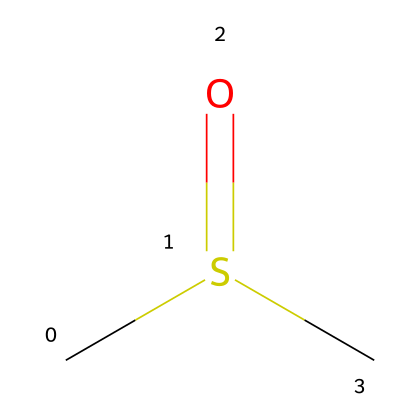What is the molecular formula of DMSO? The SMILES notation reveals the types and number of atoms present. By analyzing CS(=O)C, we deduce that there are two carbon atoms (C), one sulfur atom (S), and one oxygen atom (O) in the structure. Thus, the molecular formula combines these into C2H6OS.
Answer: C2H6OS How many carbon atoms are present in DMSO? By examining the SMILES representation, CS(=O)C, we identify that there are two "C" symbols indicating the presence of two carbon atoms in the structure.
Answer: 2 What is the hybridization of the sulfur atom in DMSO? The structure includes sulfur bonded to oxygen and carbon atoms. The sulfur in DMSO (CS(=O)C) is bonded to three other atoms (two carbons and one oxygen), indicating it is sp3 hybridized due to its tetrahedral arrangement.
Answer: sp3 What functional group does DMSO contain? The presence of the sulfoxide group, characterized by the sulfonyl (S=O) part, is identified in the structure. The oxygen double bond to sulfur (as seen in the representation) confirms that DMSO has a sulfoxide functional group.
Answer: sulfoxide Is DMSO polar or nonpolar? The polarity is determined by the presence of polar bonds and the molecule's shape. DMSO has a significant dipole moment due to the sulfur-oxygen bond’s polarity and its asymmetrical shape, thus making it a polar solvent.
Answer: polar What is the role of DMSO in forensic analysis? DMSO is used as a solvent in forensic analysis due to its ability to dissolve a wide range of substances, facilitating the extraction and preservation of evidence samples without altering them significantly.
Answer: solvent 